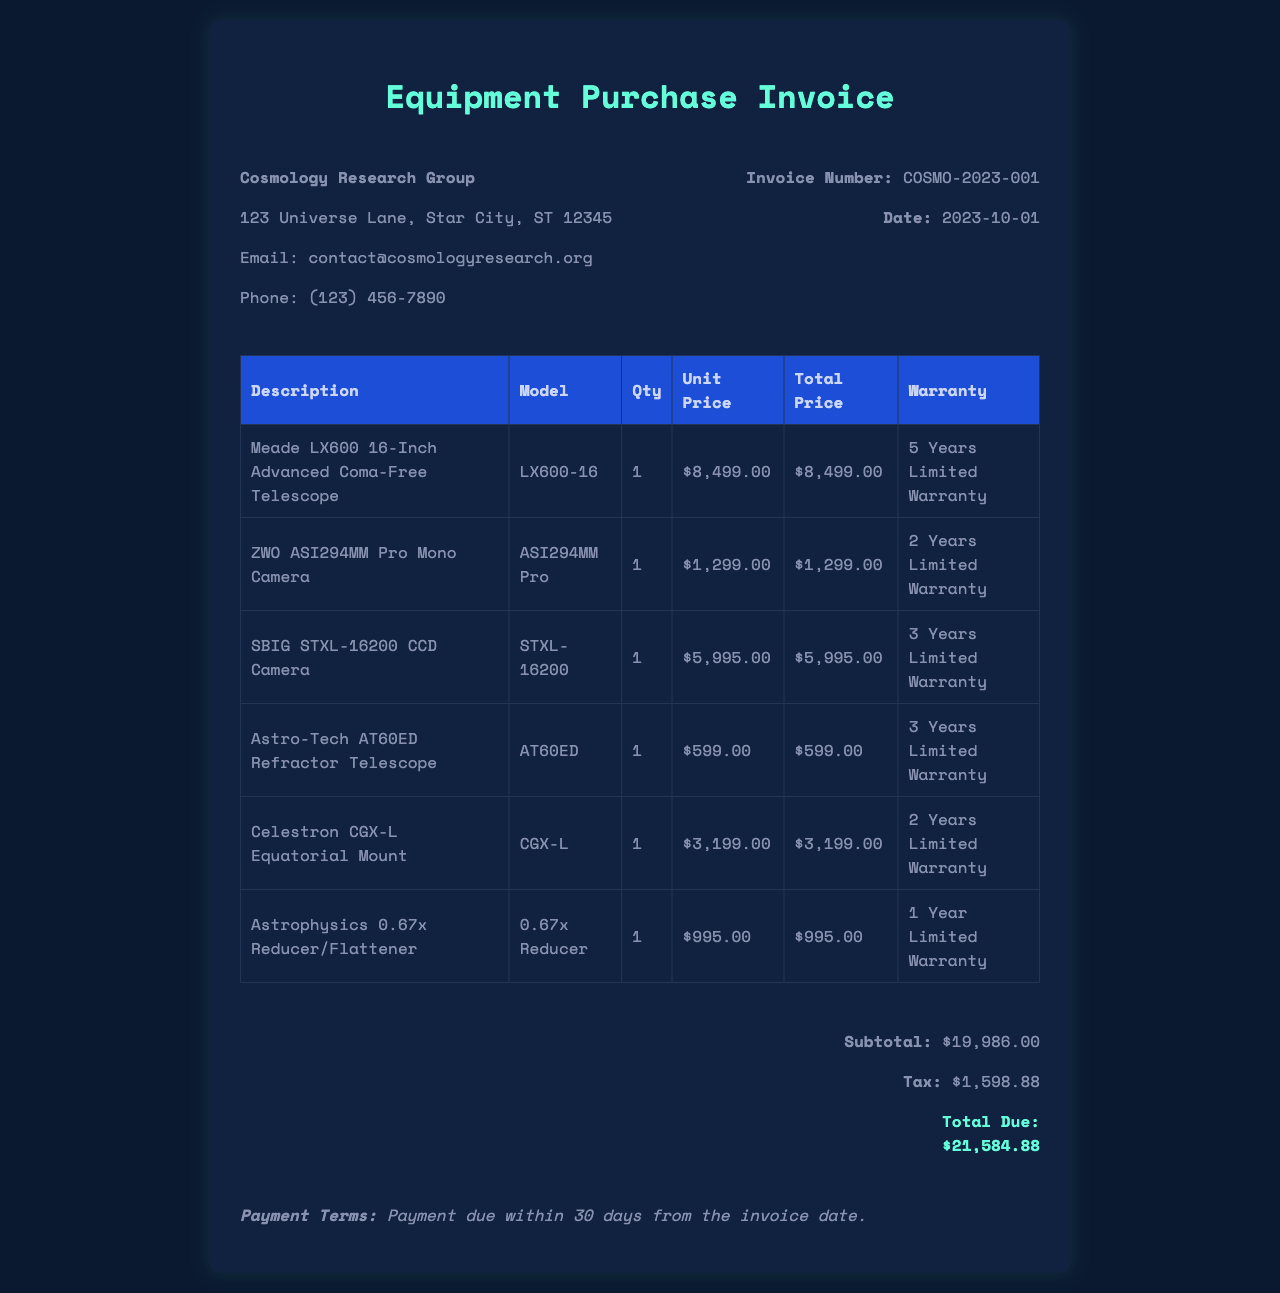What is the invoice number? The invoice number is uniquely identifying the document, which is COSMO-2023-001.
Answer: COSMO-2023-001 What is the date of the invoice? The date indicates when the invoice was issued, which is 2023-10-01.
Answer: 2023-10-01 What is the warranty for the Meade LX600 telescope? The warranty information provides detail about the coverage for the telescope, which is 5 Years Limited Warranty.
Answer: 5 Years Limited Warranty What is the subtotal of the invoice? The subtotal itemizes the total amount before tax, which is $19,986.00.
Answer: $19,986.00 What is the total amount due? The total amount due is the final amount to be paid after including tax, which is $21,584.88.
Answer: $21,584.88 How many equipment items are listed in the invoice? The number of items refers to the count of different equipment lines in the document, which is 6.
Answer: 6 What is the model number of the ZWO ASI294MM Pro camera? The model number identifies the specific version of the camera, which is ASI294MM Pro.
Answer: ASI294MM Pro What are the payment terms specified in the invoice? The payment terms indicate when the payment is due, which is Payment due within 30 days from the invoice date.
Answer: Payment due within 30 days from the invoice date 